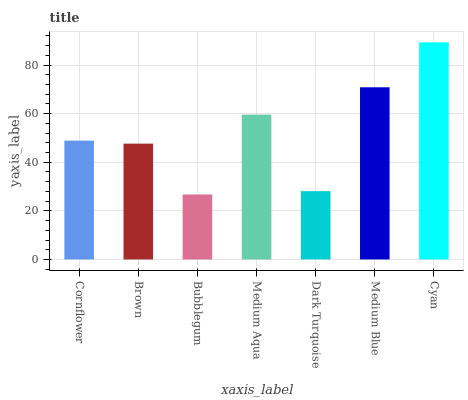Is Bubblegum the minimum?
Answer yes or no. Yes. Is Cyan the maximum?
Answer yes or no. Yes. Is Brown the minimum?
Answer yes or no. No. Is Brown the maximum?
Answer yes or no. No. Is Cornflower greater than Brown?
Answer yes or no. Yes. Is Brown less than Cornflower?
Answer yes or no. Yes. Is Brown greater than Cornflower?
Answer yes or no. No. Is Cornflower less than Brown?
Answer yes or no. No. Is Cornflower the high median?
Answer yes or no. Yes. Is Cornflower the low median?
Answer yes or no. Yes. Is Cyan the high median?
Answer yes or no. No. Is Brown the low median?
Answer yes or no. No. 